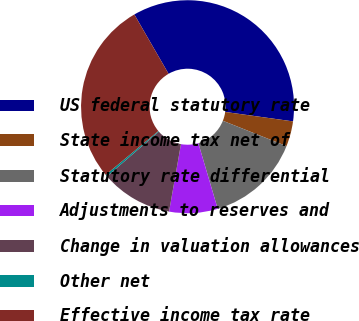Convert chart to OTSL. <chart><loc_0><loc_0><loc_500><loc_500><pie_chart><fcel>US federal statutory rate<fcel>State income tax net of<fcel>Statutory rate differential<fcel>Adjustments to reserves and<fcel>Change in valuation allowances<fcel>Other net<fcel>Effective income tax rate<nl><fcel>35.53%<fcel>3.83%<fcel>14.4%<fcel>7.35%<fcel>10.87%<fcel>0.3%<fcel>27.72%<nl></chart> 